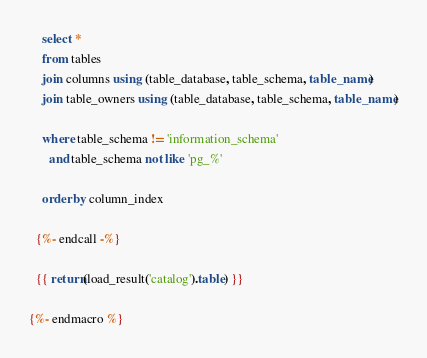<code> <loc_0><loc_0><loc_500><loc_500><_SQL_>    select *
    from tables
    join columns using (table_database, table_schema, table_name)
    join table_owners using (table_database, table_schema, table_name)

    where table_schema != 'information_schema'
      and table_schema not like 'pg_%'

    order by column_index

  {%- endcall -%}

  {{ return(load_result('catalog').table) }}

{%- endmacro %}
</code> 